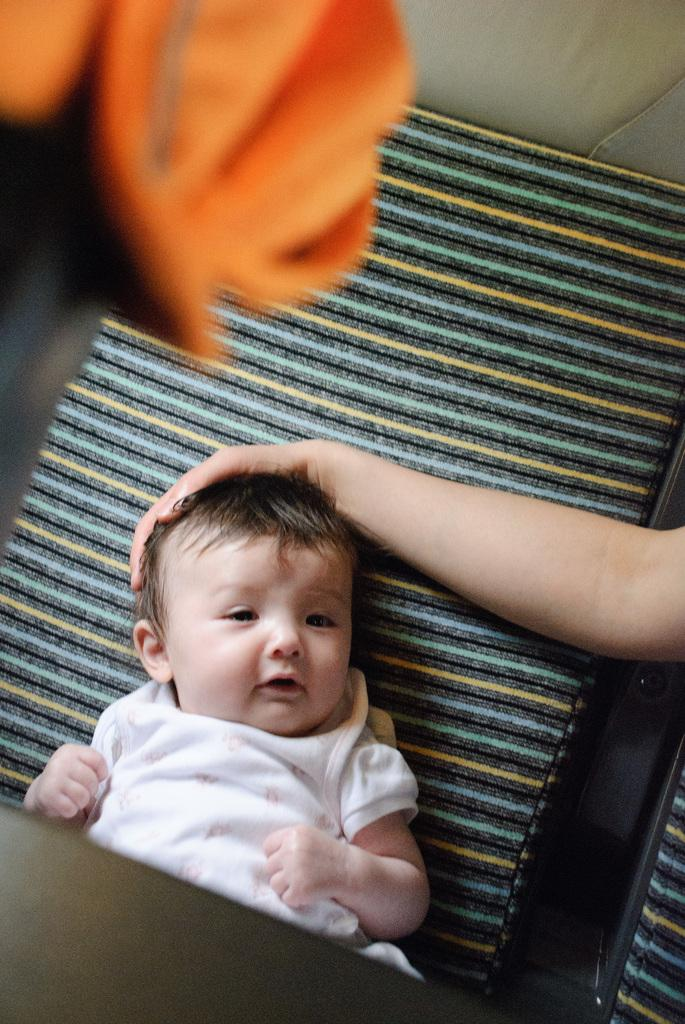What is the main subject of the image? There is a kid in the image. Can you describe any other elements in the image? There is a hand of a person in the image. Where is the hand of the person located? The hand of the person is on a platform. What type of pig can be seen participating in the battle in the image? There is no pig or battle present in the image. How does the person in the image show care for the kid? The image does not show any specific actions of care for the kid, as it only depicts the hand of a person on a platform. 